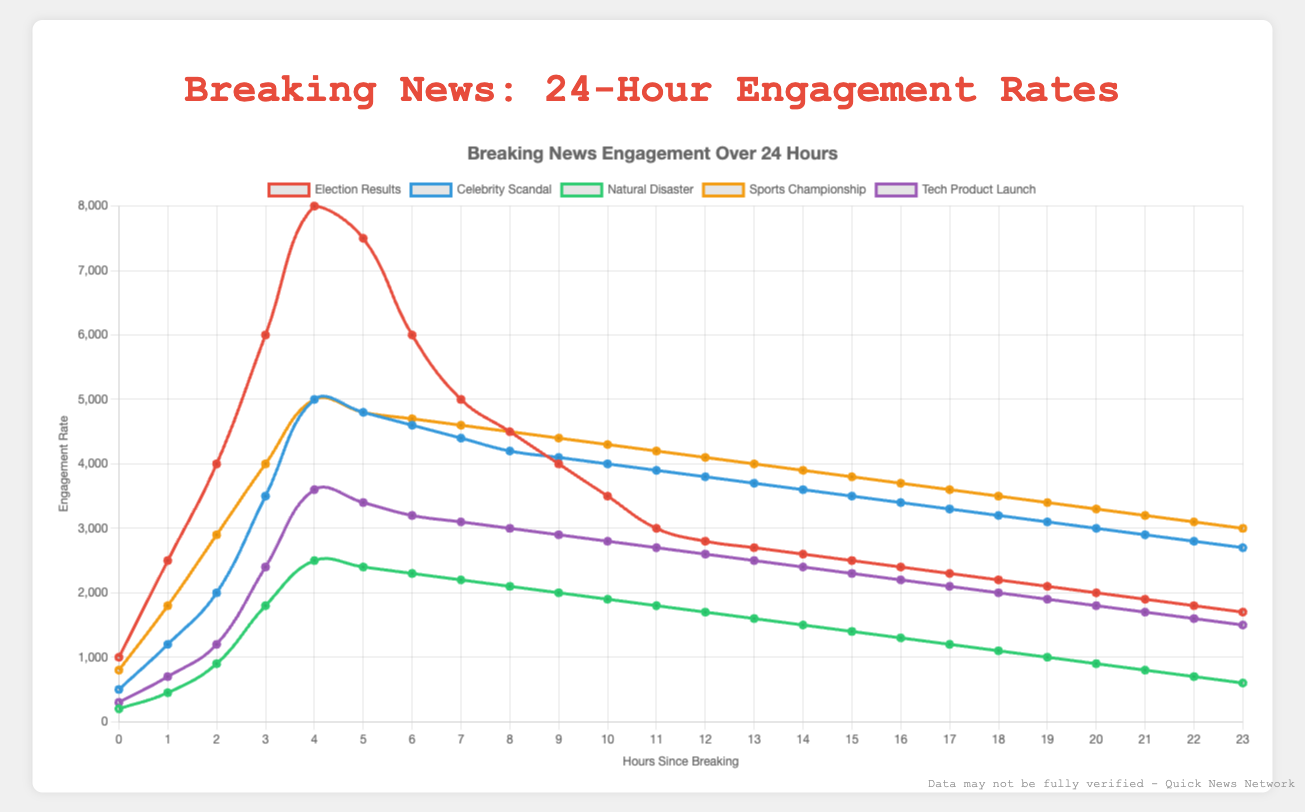Which news story has the highest engagement rate at hour 4? At hour 4, we look at the heights of each curve corresponding to different news stories. The tallest curve at this hour is for "Election Results" with 8000 engagements.
Answer: Election Results Compare the engagement drop between hours 4 and 5 for the "Election Results" and "Celebrity Scandal" stories. Which one showed a larger decrease? For "Election Results," the engagement drops from 8000 to 7500, a decrease of 500. For "Celebrity Scandal," the drop is from 5000 to 4800, a decrease of 200. 500 is greater than 200, so "Election Results" showed a larger decrease.
Answer: Election Results Which news story shows the flattest engagement curve between hours 10 and 15? Between hours 10 and 15, "Sports Championship" shows the least decline, maintaining an almost steady rate between 4300 and 3800 engagements. Other stories show steeper declines.
Answer: Sports Championship What is the total engagement for the "Natural Disaster" story over the first three hours? Summing the engagements for "Natural Disaster" from hours 0 to 2: 200 (hour 0) + 450 (hour 1) + 900 (hour 2) = 1550.
Answer: 1550 By how much does the engagement rate drop for the "Tech Product Launch" story between hour 4 and hour 23? Initially, at hour 4 the engagement is 3600, and by hour 23 it is 1500. The drop is 3600 - 1500 = 2100.
Answer: 2100 Which story demonstrates the highest peak in engagement rate, and what is the value? The "Election Results" story reaches its peak at hour 4 with an engagement rate of 8000, which is the highest among all stories.
Answer: Election Results, 8000 Compare the total engagement from hour 4 to hour 7 for "Celebrity Scandal" and "Sports Championship". Which one is higher? Adding engagements for hours 4 to 7: Celebrity Scandal: 5000 + 4800 + 4600 + 4400 = 18800. Sports Championship: 5000 + 4800 + 4700 + 4600 = 19100. "Sports Championship" has a higher total.
Answer: Sports Championship Calculate the average engagement rate over the first five hours for the "Tech Product Launch" story. Summing engagements from hours 0 to 4: 300 + 700 + 1200 + 2400 + 3600 = 8200. Dividing by 5 gives the average: 8200 / 5 = 1640.
Answer: 1640 Which news story has the quickest rise in engagement rate within the first three hours? Checking the rise from hour 0 to hour 3 for each story, "Election Results" rises the fastest, going from 1000 to 6000 in 3 hours (a rise of 5000 engagements).
Answer: Election Results What is the difference in engagement rate between hour 5 and hour 22 for the "Celebrity Scandal" story? At hour 5, engagements are 4800 and at hour 22, they are 2800. The difference is 4800 - 2800 = 2000.
Answer: 2000 